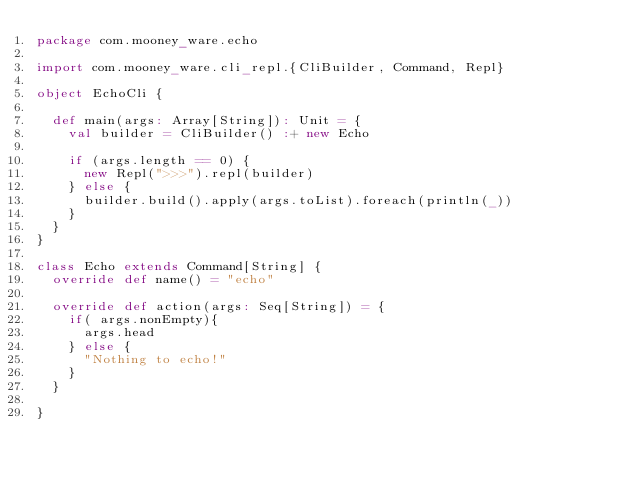<code> <loc_0><loc_0><loc_500><loc_500><_Scala_>package com.mooney_ware.echo

import com.mooney_ware.cli_repl.{CliBuilder, Command, Repl}

object EchoCli {

  def main(args: Array[String]): Unit = {
    val builder = CliBuilder() :+ new Echo

    if (args.length == 0) {
      new Repl(">>>").repl(builder)
    } else {
      builder.build().apply(args.toList).foreach(println(_))
    }
  }
}

class Echo extends Command[String] {
  override def name() = "echo"

  override def action(args: Seq[String]) = {
    if( args.nonEmpty){
      args.head
    } else {
      "Nothing to echo!"
    }
  }

}
</code> 